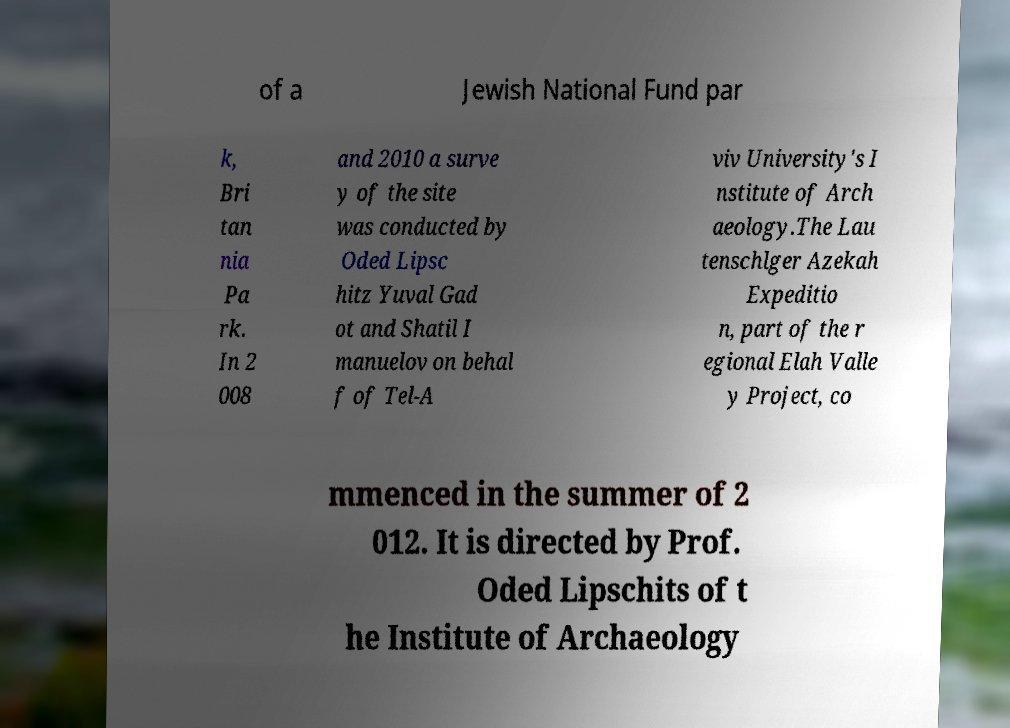Please identify and transcribe the text found in this image. of a Jewish National Fund par k, Bri tan nia Pa rk. In 2 008 and 2010 a surve y of the site was conducted by Oded Lipsc hitz Yuval Gad ot and Shatil I manuelov on behal f of Tel-A viv University's I nstitute of Arch aeology.The Lau tenschlger Azekah Expeditio n, part of the r egional Elah Valle y Project, co mmenced in the summer of 2 012. It is directed by Prof. Oded Lipschits of t he Institute of Archaeology 